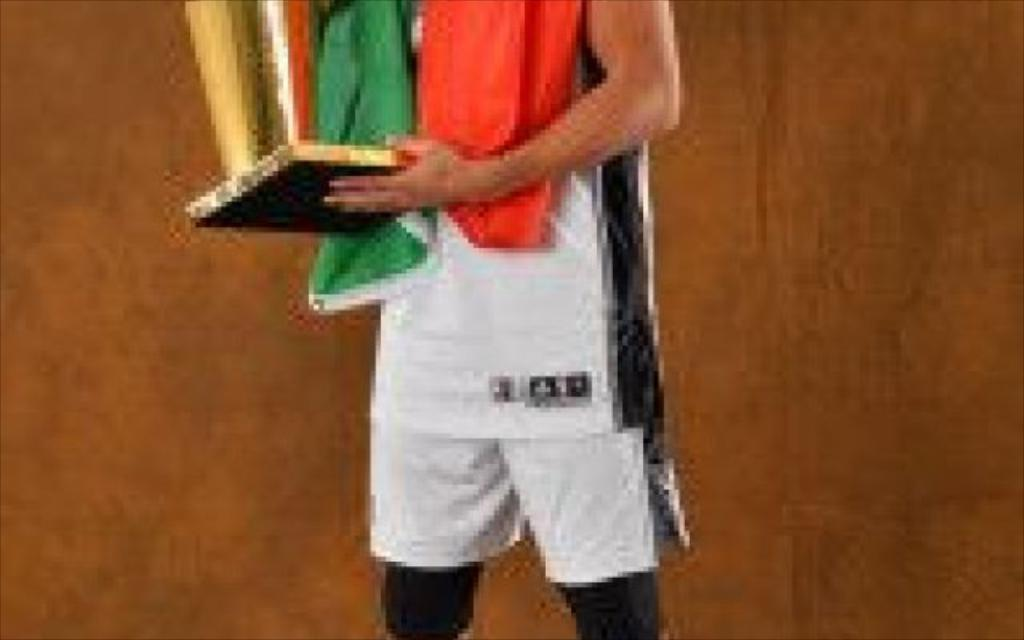What is the main subject of the image? There is a person in the image. What is the person holding in the image? The person is holding a trophy. Can you describe the background of the image? The background of the image is brown. How many geese are visible in the image? There are no geese present in the image. What emotion is the person in the image feeling? The image does not provide information about the person's emotions. 